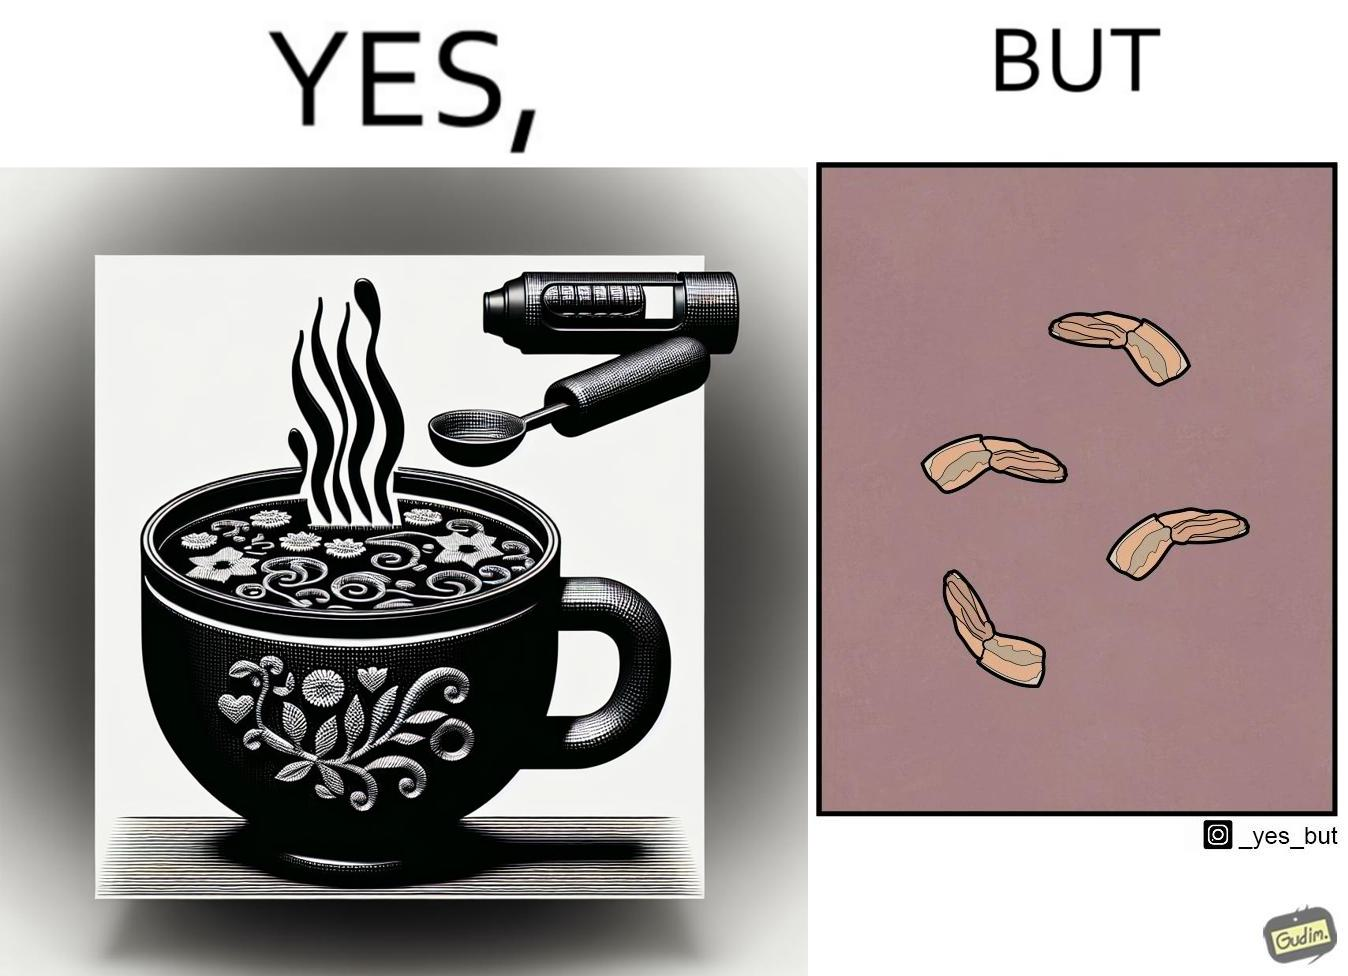What do you see in each half of this image? In the left part of the image: There is a cup of soup. In the right part of the image: Vegetables that are left. 